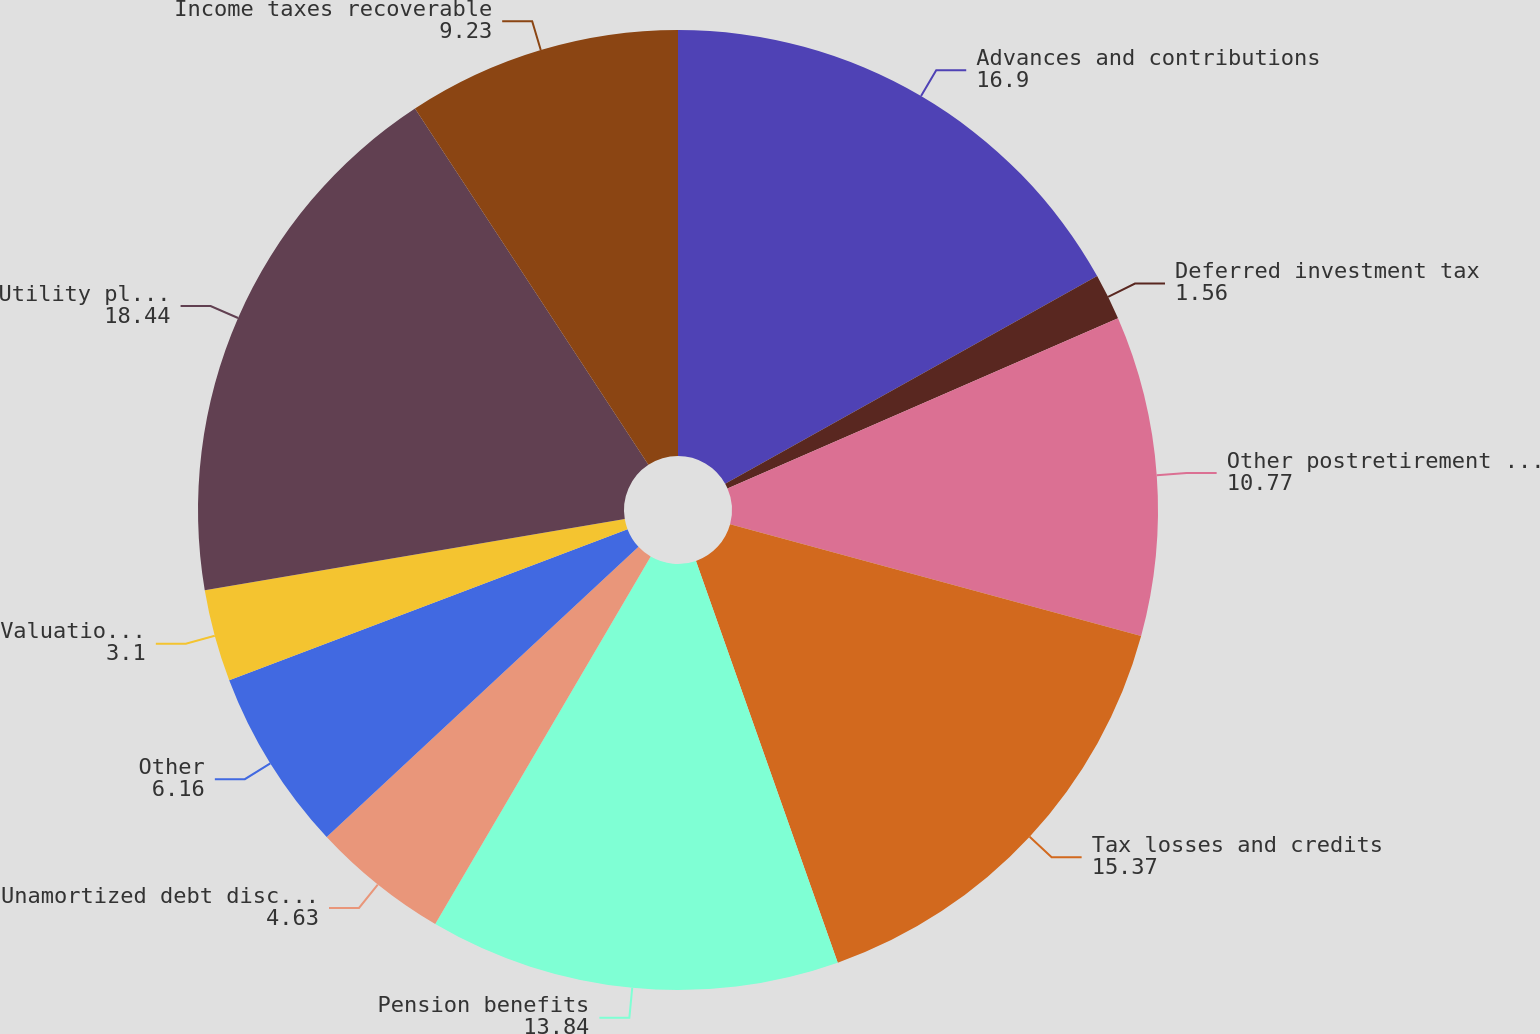Convert chart. <chart><loc_0><loc_0><loc_500><loc_500><pie_chart><fcel>Advances and contributions<fcel>Deferred investment tax<fcel>Other postretirement benefits<fcel>Tax losses and credits<fcel>Pension benefits<fcel>Unamortized debt discount net<fcel>Other<fcel>Valuation allowance<fcel>Utility plant principally due<fcel>Income taxes recoverable<nl><fcel>16.9%<fcel>1.56%<fcel>10.77%<fcel>15.37%<fcel>13.84%<fcel>4.63%<fcel>6.16%<fcel>3.1%<fcel>18.44%<fcel>9.23%<nl></chart> 